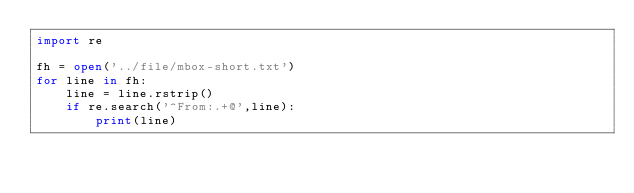<code> <loc_0><loc_0><loc_500><loc_500><_Python_>import re

fh = open('../file/mbox-short.txt')
for line in fh:
    line = line.rstrip()
    if re.search('^From:.+@',line):
        print(line)
</code> 